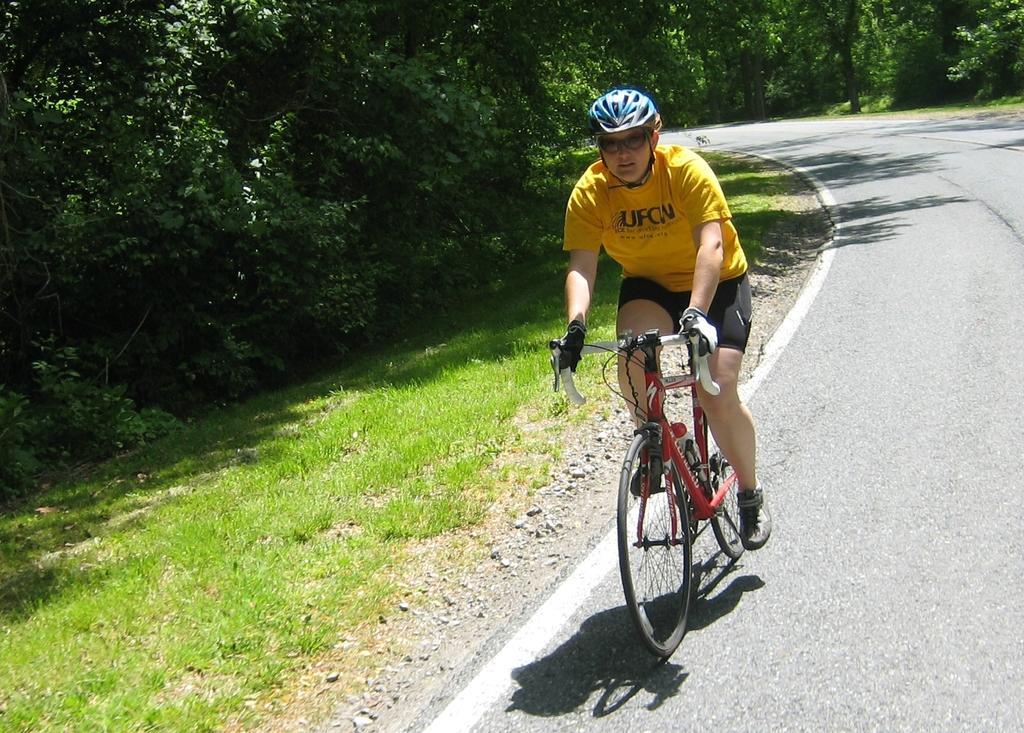In one or two sentences, can you explain what this image depicts? This is the picture of a road. In this image there is a person with yellow t-shirt is riding bicycle on the road. At the back there are trees. At the bottom there is grass and there is a road. 